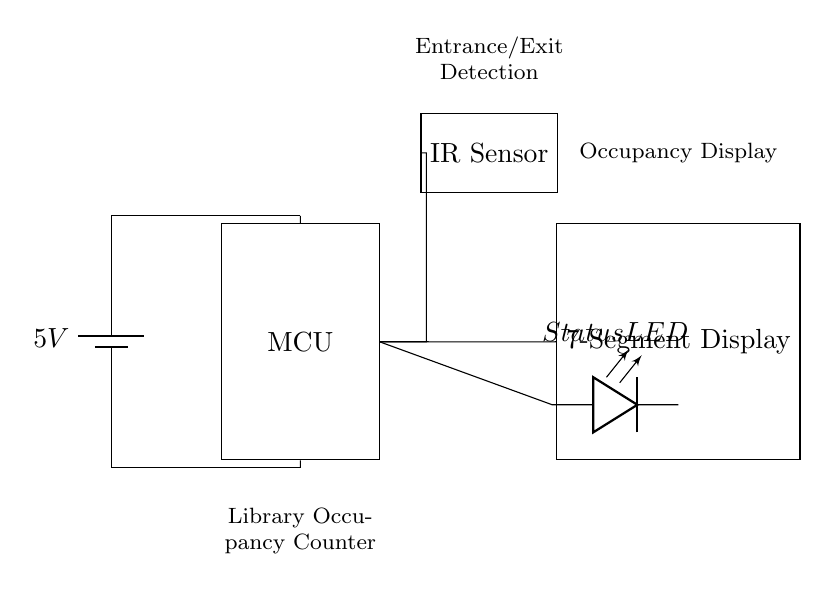What is the voltage of this circuit? The circuit is powered by a battery indicated at the beginning, which shows a voltage of 5 volts. This voltage powers the entire circuit, and it is connected to the microcontroller and other components.
Answer: 5 volts What type of sensor is used for detection? The circuit includes an IR sensor, which is specifically labeled in the diagram. This sensor detects entrance and exit movements, enabling the occupancy counting function of the library.
Answer: IR sensor Where is the status indicator located? The status LED is located towards the right side of the microcontroller and is connected directly to it. The LED indicates the status of the occupancy counter by lighting up based on the conditions programmed into the microcontroller.
Answer: Status LED How many main components are present in this circuit? By examining the circuit diagram, we can identify four main components: the battery, microcontroller, IR sensor, and 7-segment display. The LED is also present but is considered part of the status indication.
Answer: Four What is the purpose of the 7-segment display in this circuit? The 7-segment display is positioned to the right of the microcontroller and is labeled as "Occupancy Display." Its purpose is to visually show the real-time count of library occupancy, thus providing users with immediate information.
Answer: Real-time occupancy display What is the role of the microcontroller in this circuit? The microcontroller serves as the central processing unit that controls the entire system. It processes inputs from the IR sensor to determine occupancy levels and outputs the data to the 7-segment display, thereby executing the logic of counting and display.
Answer: Central processing unit What does the connection from the IR sensor to the microcontroller indicate? The connection signifies that the IR sensor provides data regarding presence or absence at the entrance and exit, which the microcontroller uses to update the occupancy count. This interaction is crucial for the functionality of the occupancy counter.
Answer: Data input for occupancy counting 